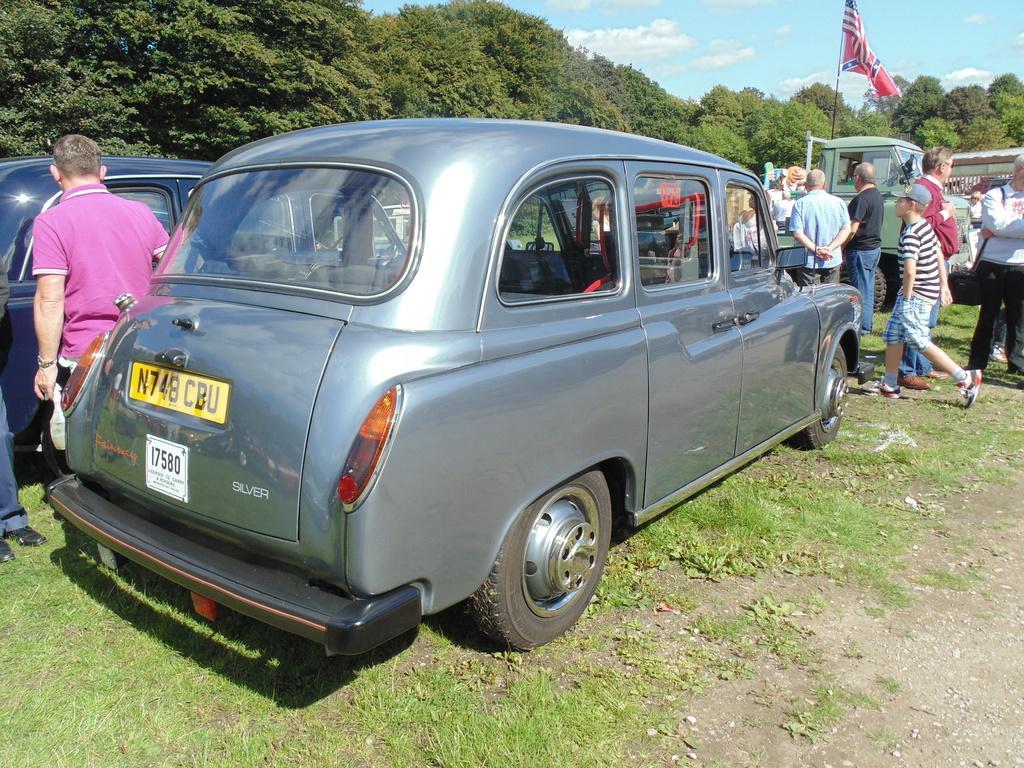Please provide a concise description of this image. This image is taken outdoors. At the bottom of the image there is a ground with grass on it. At the top of the image there is a sky. In the background there are many trees. In the middle of the image a few vehicles are parked on the ground. A few people are standing on the ground and a few are walking and there is a flag. 